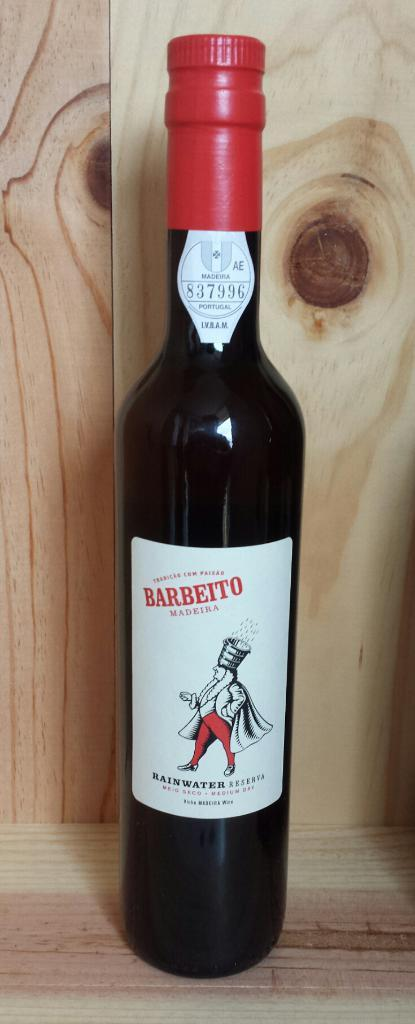<image>
Give a short and clear explanation of the subsequent image. The Barbeito bottle has the serial numbers "837996" printed at the top of the bottle. 